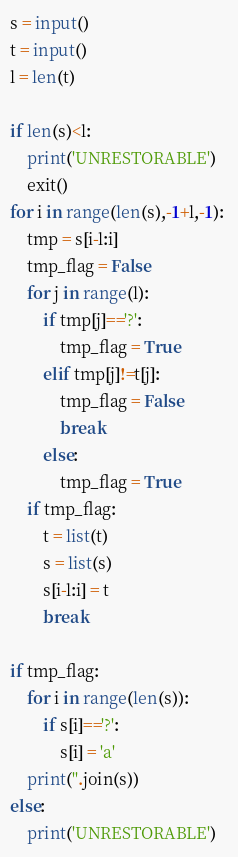<code> <loc_0><loc_0><loc_500><loc_500><_Python_>s = input()
t = input()
l = len(t)

if len(s)<l:
    print('UNRESTORABLE')   
    exit() 
for i in range(len(s),-1+l,-1):
    tmp = s[i-l:i]
    tmp_flag = False
    for j in range(l):
        if tmp[j]=='?':
            tmp_flag = True
        elif tmp[j]!=t[j]:
            tmp_flag = False
            break
        else:
            tmp_flag = True
    if tmp_flag:
        t = list(t)
        s = list(s)
        s[i-l:i] = t
        break

if tmp_flag:
    for i in range(len(s)):
        if s[i]=='?':
            s[i] = 'a'
    print(''.join(s))
else:
    print('UNRESTORABLE')
</code> 